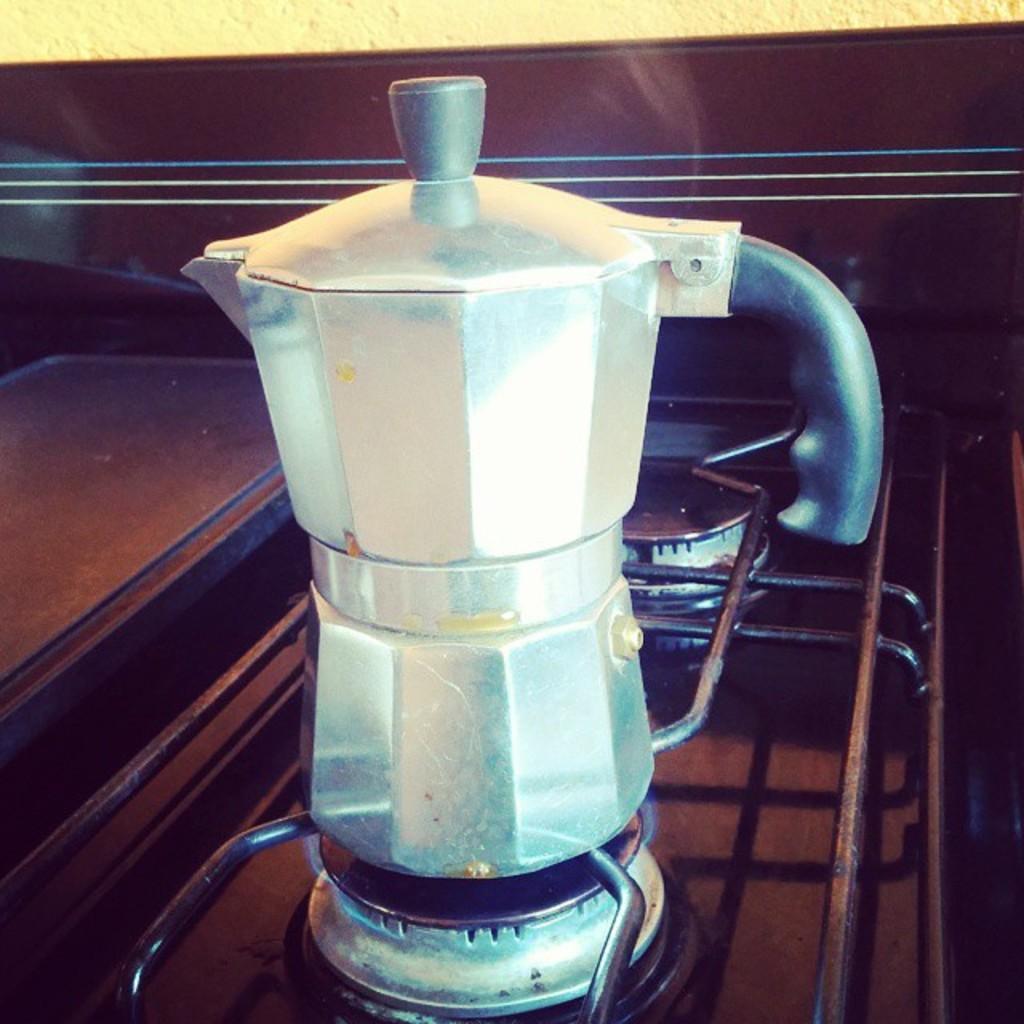How would you summarize this image in a sentence or two? In this image I can see a jar kept on the wooden table 